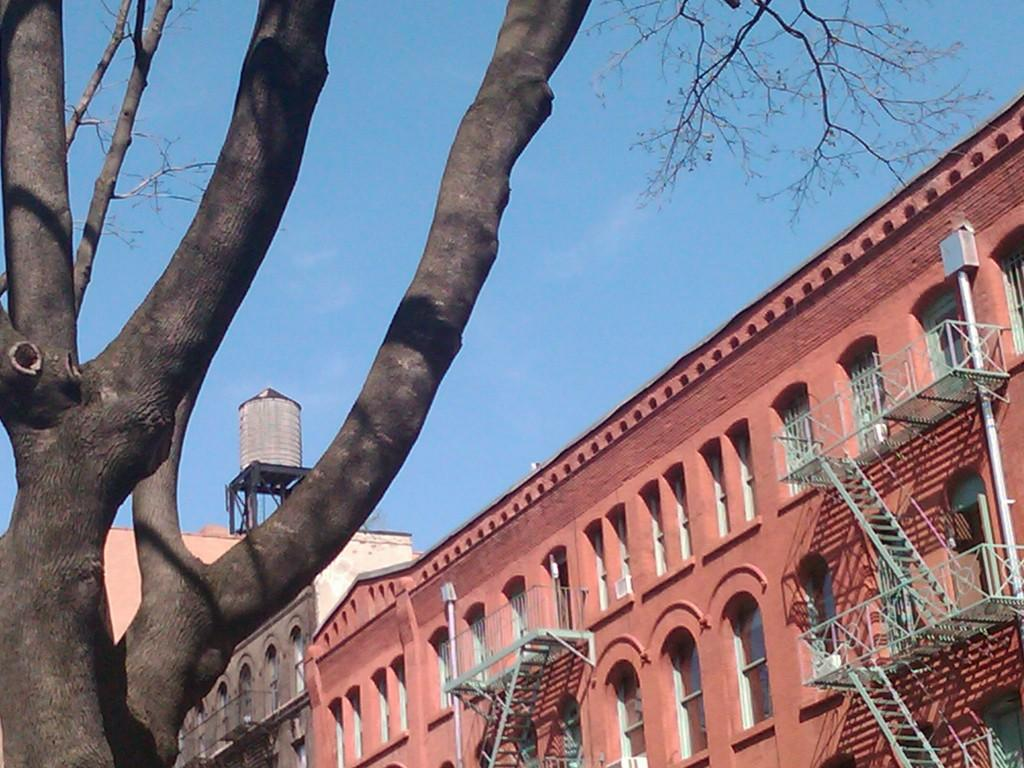What type of natural element can be seen in the image? There is a tree in the image. What type of man-made structures are present in the image? There are buildings in the image. What type of architectural feature can be seen in the image? Railings are present in the image. What type of infrastructure is visible in the image? Pipes are visible in the image. What type of openings are present in the buildings in the image? Windows are present in the image. What type of equipment is present in the image? There is a tank on a stand in the image. What can be seen in the background of the image? The sky is visible in the background of the image. What type of insurance policy is being discussed in the image? There is no discussion of insurance policies in the image. What type of birth announcement is being made in the image? There is no birth announcement in the image. 